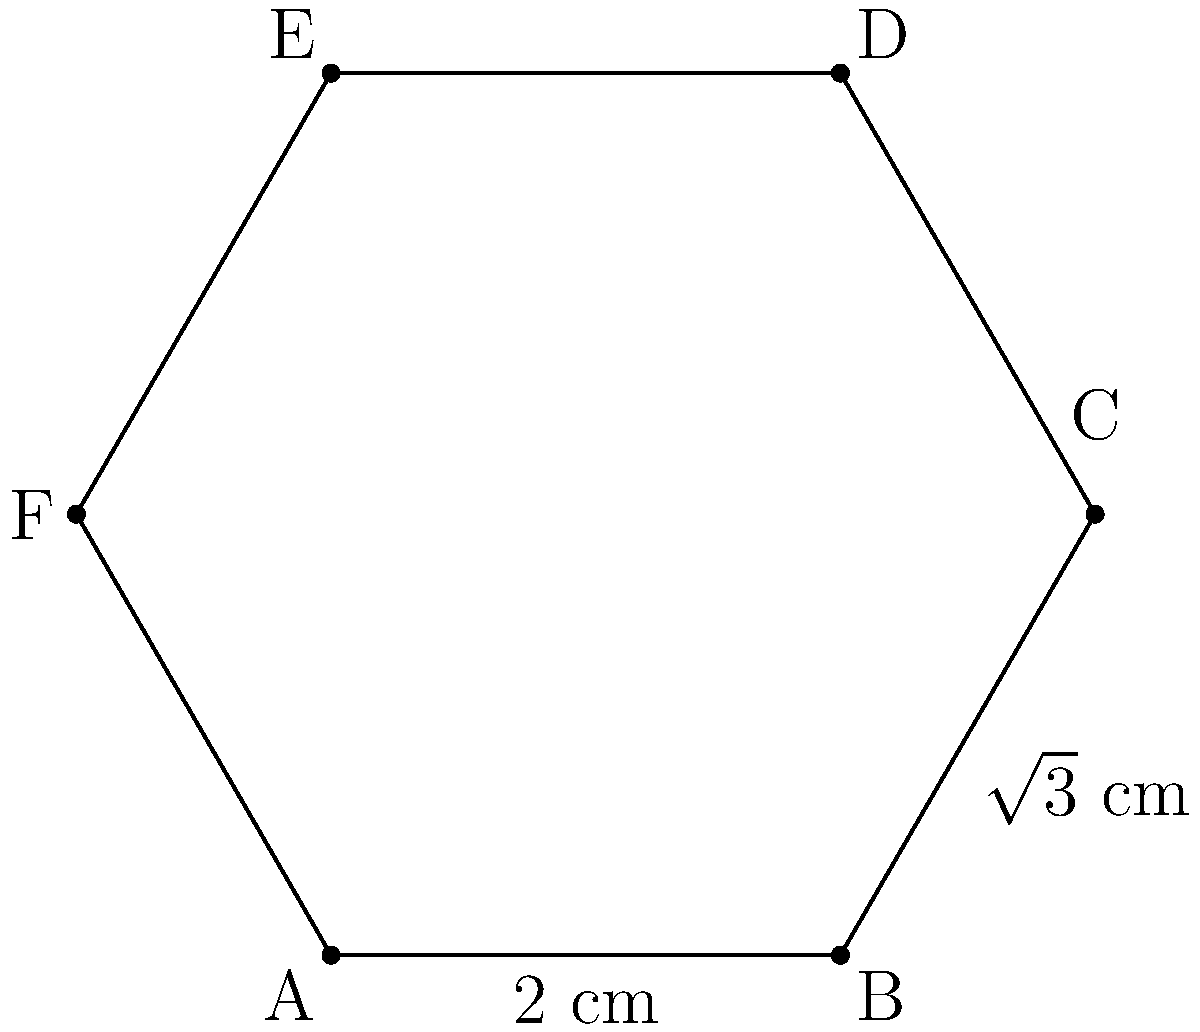Your daughter is designing a custom hexagonal compact powder case for her makeup line. The case has a side length of 2 cm and a height of 1 cm. What is the total surface area of the compact powder case, including the top, bottom, and all sides? Let's break this down step-by-step:

1) First, we need to calculate the area of the hexagonal top and bottom:
   - Area of a regular hexagon = $\frac{3\sqrt{3}}{2}a^2$, where $a$ is the side length
   - $A_{hexagon} = \frac{3\sqrt{3}}{2}(2^2) = 6\sqrt{3}$ cm²
   - We have two hexagonal faces (top and bottom), so the total area is $12\sqrt{3}$ cm²

2) Next, we calculate the area of the six rectangular sides:
   - Each rectangle has a width of 2 cm (side length of hexagon) and a height of 1 cm
   - Area of each rectangle = $2 \times 1 = 2$ cm²
   - There are 6 sides, so the total area of the sides is $6 \times 2 = 12$ cm²

3) Now, we sum up all the areas:
   - Total surface area = Area of top and bottom + Area of sides
   - Total surface area = $12\sqrt{3} + 12$ cm²

4) Simplify the expression:
   - Total surface area = $12(\sqrt{3} + 1)$ cm²
Answer: $12(\sqrt{3} + 1)$ cm² 